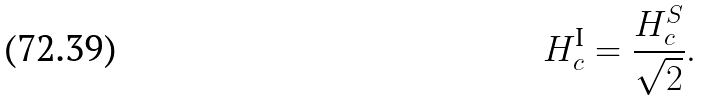<formula> <loc_0><loc_0><loc_500><loc_500>H _ { c } ^ { \text {I} } = \frac { H _ { c } ^ { S } } { \sqrt { 2 } } .</formula> 